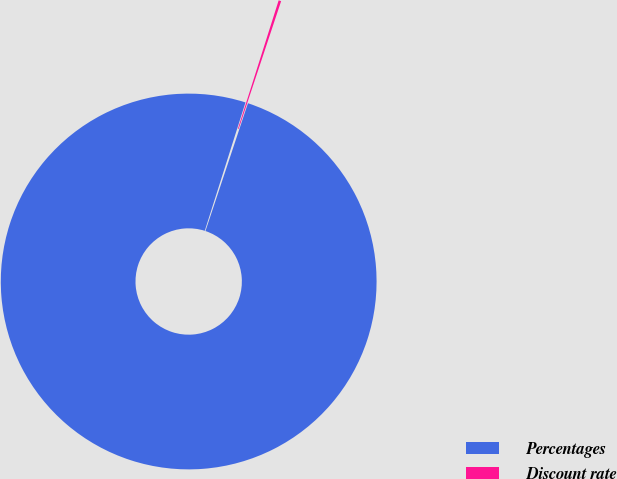<chart> <loc_0><loc_0><loc_500><loc_500><pie_chart><fcel>Percentages<fcel>Discount rate<nl><fcel>99.78%<fcel>0.22%<nl></chart> 